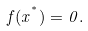<formula> <loc_0><loc_0><loc_500><loc_500>f ( x ^ { ^ { * } } ) = 0 .</formula> 